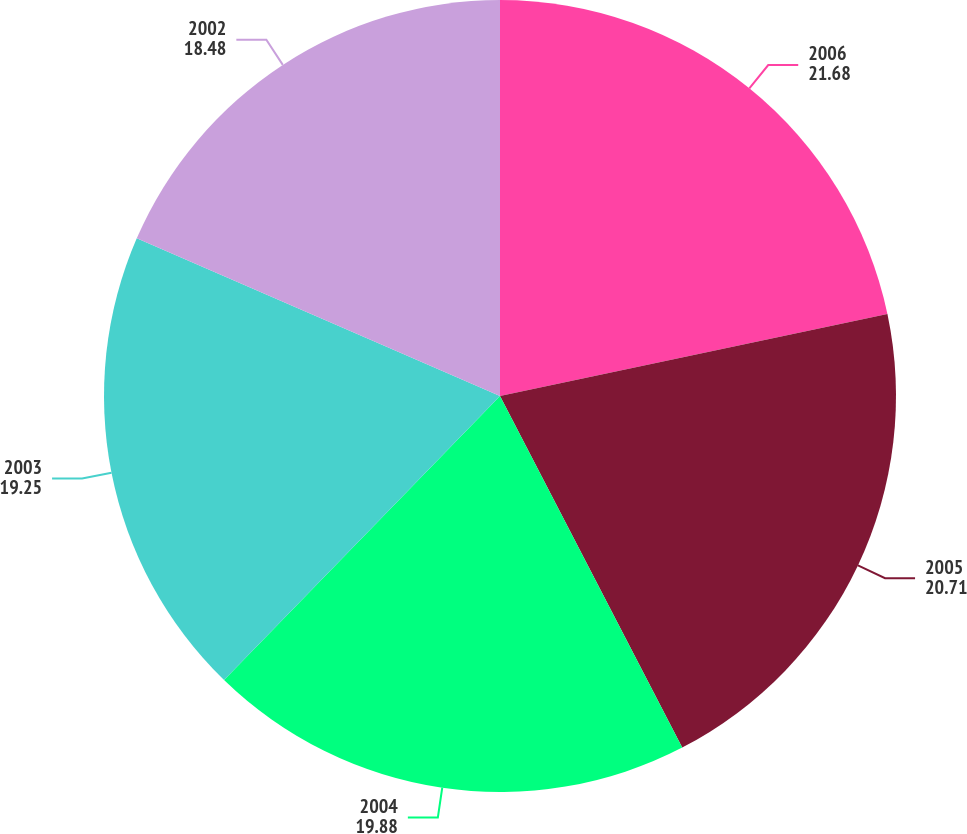Convert chart. <chart><loc_0><loc_0><loc_500><loc_500><pie_chart><fcel>2006<fcel>2005<fcel>2004<fcel>2003<fcel>2002<nl><fcel>21.68%<fcel>20.71%<fcel>19.88%<fcel>19.25%<fcel>18.48%<nl></chart> 